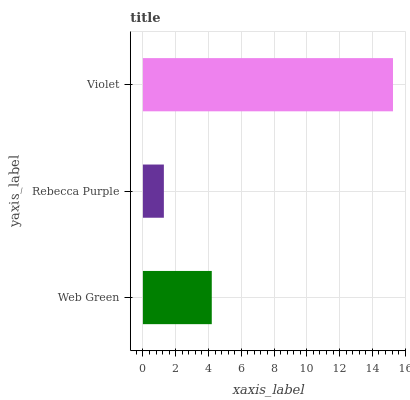Is Rebecca Purple the minimum?
Answer yes or no. Yes. Is Violet the maximum?
Answer yes or no. Yes. Is Violet the minimum?
Answer yes or no. No. Is Rebecca Purple the maximum?
Answer yes or no. No. Is Violet greater than Rebecca Purple?
Answer yes or no. Yes. Is Rebecca Purple less than Violet?
Answer yes or no. Yes. Is Rebecca Purple greater than Violet?
Answer yes or no. No. Is Violet less than Rebecca Purple?
Answer yes or no. No. Is Web Green the high median?
Answer yes or no. Yes. Is Web Green the low median?
Answer yes or no. Yes. Is Violet the high median?
Answer yes or no. No. Is Violet the low median?
Answer yes or no. No. 